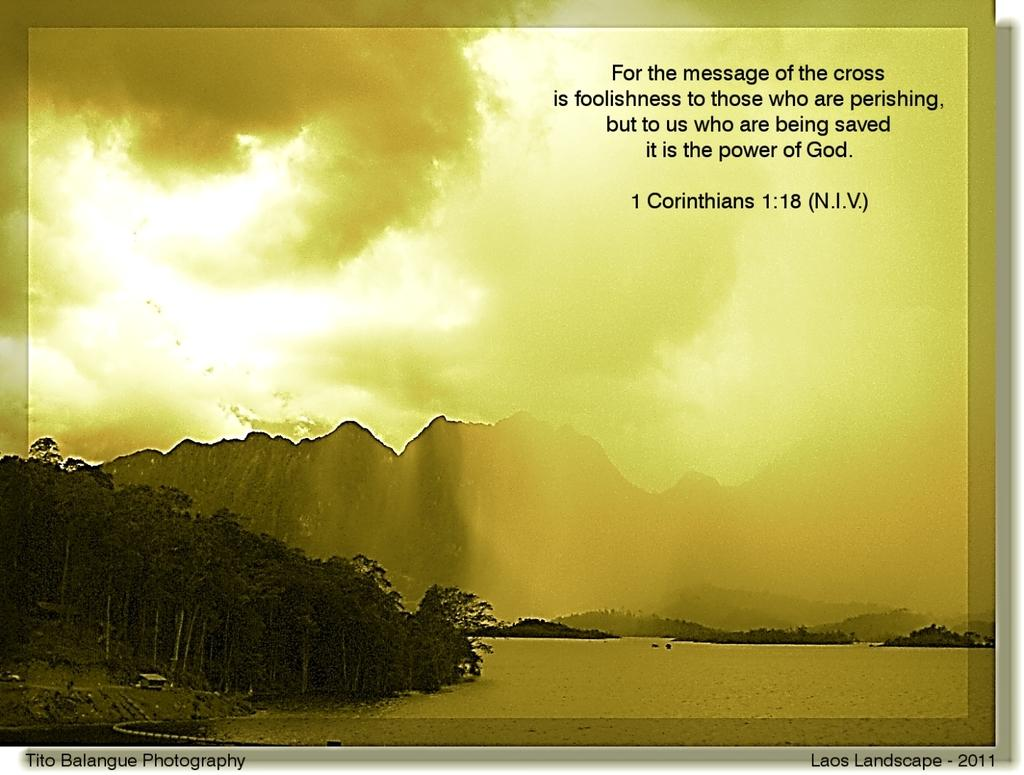<image>
Present a compact description of the photo's key features. A photograph taken by Tito Balangue Photography called Laos Landscape 2011 